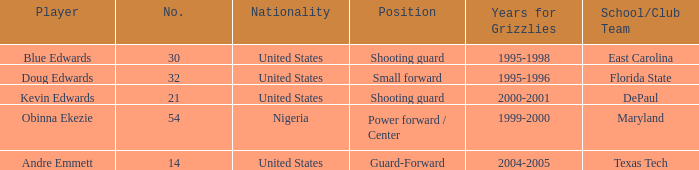Could you help me parse every detail presented in this table? {'header': ['Player', 'No.', 'Nationality', 'Position', 'Years for Grizzlies', 'School/Club Team'], 'rows': [['Blue Edwards', '30', 'United States', 'Shooting guard', '1995-1998', 'East Carolina'], ['Doug Edwards', '32', 'United States', 'Small forward', '1995-1996', 'Florida State'], ['Kevin Edwards', '21', 'United States', 'Shooting guard', '2000-2001', 'DePaul'], ['Obinna Ekezie', '54', 'Nigeria', 'Power forward / Center', '1999-2000', 'Maryland'], ['Andre Emmett', '14', 'United States', 'Guard-Forward', '2004-2005', 'Texas Tech']]} In which position did kevin edwards participate? Shooting guard. 